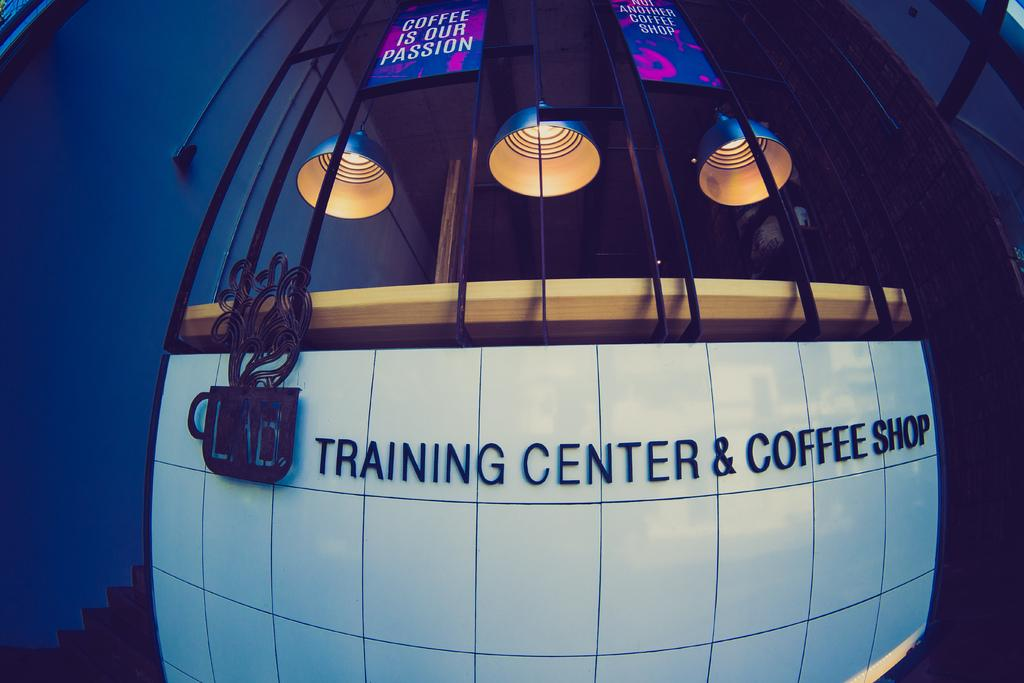<image>
Relay a brief, clear account of the picture shown. a building called trining center and coffee shop 